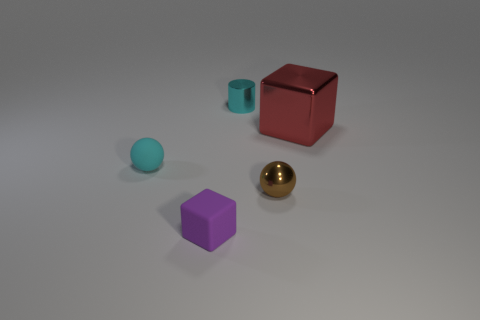Subtract all cylinders. How many objects are left? 4 Subtract 0 blue cylinders. How many objects are left? 5 Subtract 2 balls. How many balls are left? 0 Subtract all gray balls. Subtract all purple cubes. How many balls are left? 2 Subtract all green blocks. How many red balls are left? 0 Subtract all green metallic objects. Subtract all tiny metallic balls. How many objects are left? 4 Add 4 metallic cubes. How many metallic cubes are left? 5 Add 3 blue cylinders. How many blue cylinders exist? 3 Add 5 green rubber cylinders. How many objects exist? 10 Subtract all red cubes. How many cubes are left? 1 